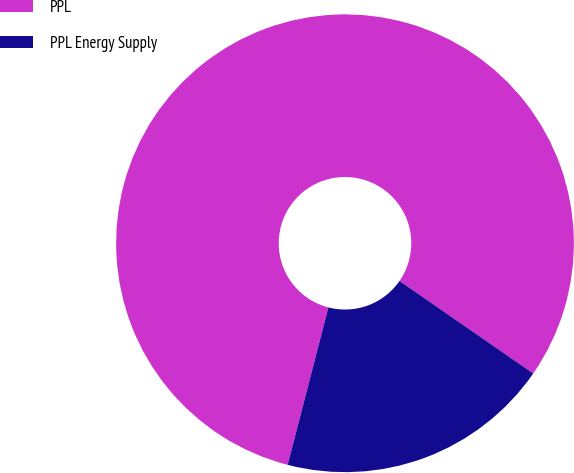Convert chart. <chart><loc_0><loc_0><loc_500><loc_500><pie_chart><fcel>PPL<fcel>PPL Energy Supply<nl><fcel>80.6%<fcel>19.4%<nl></chart> 